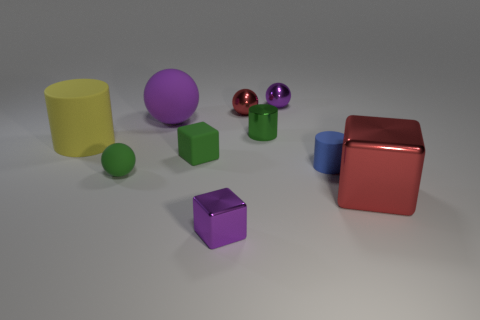What material is the large purple thing?
Your answer should be compact. Rubber. There is a small shiny cylinder; is it the same color as the small rubber object left of the large matte ball?
Offer a terse response. Yes. How many spheres are red metallic things or tiny purple objects?
Provide a succinct answer. 2. The ball in front of the big purple matte object is what color?
Ensure brevity in your answer.  Green. What shape is the metal thing that is the same color as the big metallic block?
Give a very brief answer. Sphere. How many blue cylinders have the same size as the green cylinder?
Your answer should be very brief. 1. Is the shape of the tiny purple shiny thing on the left side of the metal cylinder the same as the green thing behind the yellow matte cylinder?
Your response must be concise. No. The purple object in front of the matte cylinder that is in front of the block that is behind the large metal thing is made of what material?
Ensure brevity in your answer.  Metal. There is a blue thing that is the same size as the red metal sphere; what is its shape?
Provide a short and direct response. Cylinder. Are there any tiny shiny cylinders that have the same color as the tiny matte cylinder?
Your answer should be compact. No. 